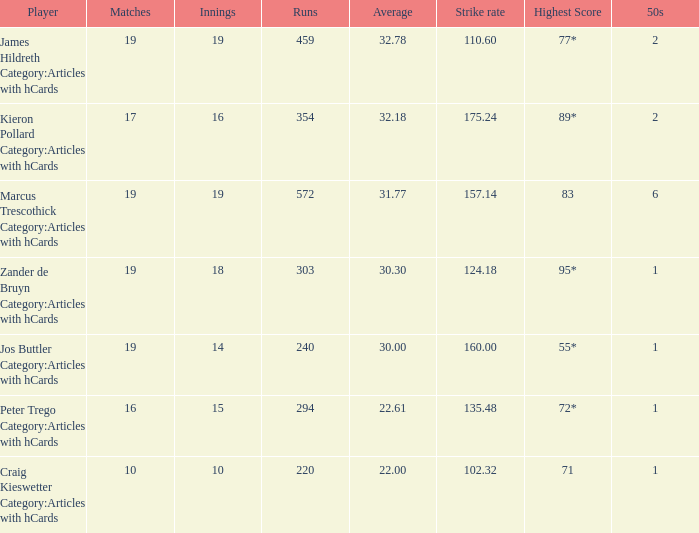00? 55*. 